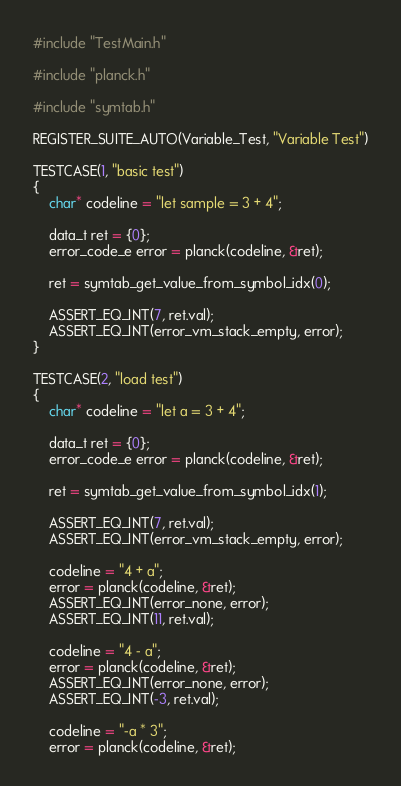<code> <loc_0><loc_0><loc_500><loc_500><_C_>#include "TestMain.h"

#include "planck.h"

#include "symtab.h"

REGISTER_SUITE_AUTO(Variable_Test, "Variable Test")

TESTCASE(1, "basic test")
{
    char* codeline = "let sample = 3 + 4";

    data_t ret = {0};
    error_code_e error = planck(codeline, &ret);

    ret = symtab_get_value_from_symbol_idx(0);

    ASSERT_EQ_INT(7, ret.val);
    ASSERT_EQ_INT(error_vm_stack_empty, error);
}

TESTCASE(2, "load test")
{
    char* codeline = "let a = 3 + 4";

    data_t ret = {0};
    error_code_e error = planck(codeline, &ret);

    ret = symtab_get_value_from_symbol_idx(1);

    ASSERT_EQ_INT(7, ret.val);
    ASSERT_EQ_INT(error_vm_stack_empty, error);

    codeline = "4 + a";
    error = planck(codeline, &ret);
    ASSERT_EQ_INT(error_none, error);
    ASSERT_EQ_INT(11, ret.val);

    codeline = "4 - a";
    error = planck(codeline, &ret);
    ASSERT_EQ_INT(error_none, error);
    ASSERT_EQ_INT(-3, ret.val);

    codeline = "-a * 3";
    error = planck(codeline, &ret);</code> 